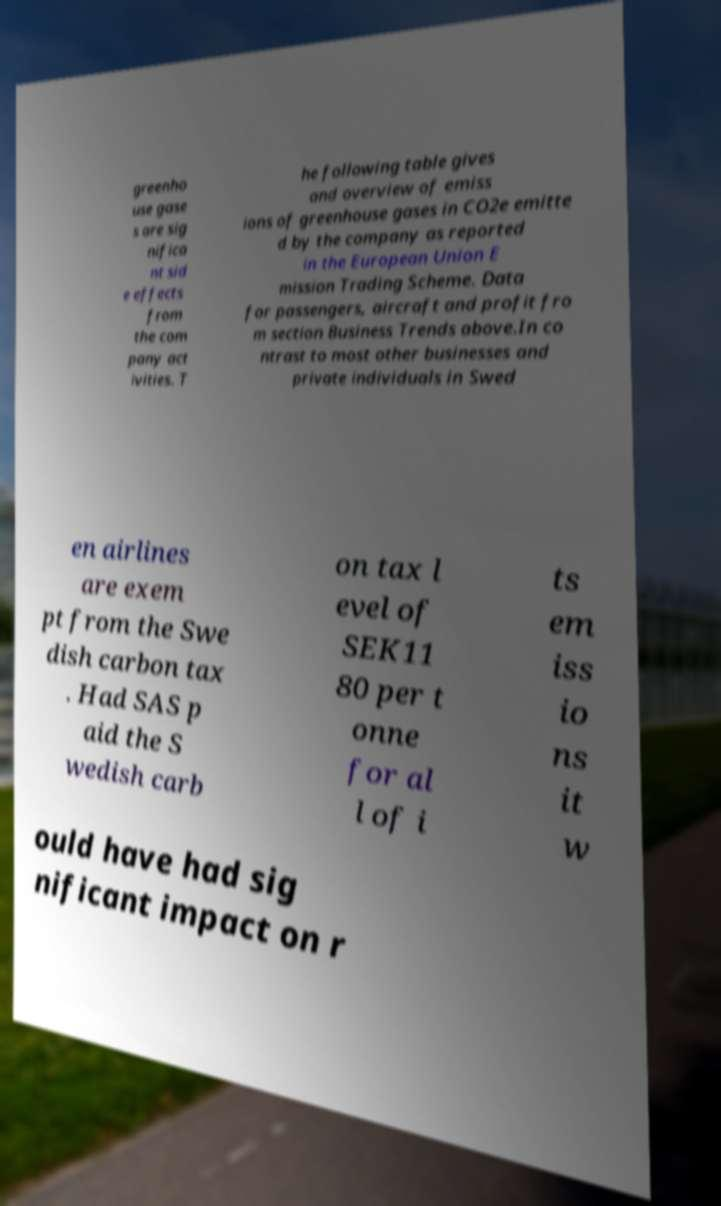What messages or text are displayed in this image? I need them in a readable, typed format. greenho use gase s are sig nifica nt sid e effects from the com pany act ivities. T he following table gives and overview of emiss ions of greenhouse gases in CO2e emitte d by the company as reported in the European Union E mission Trading Scheme. Data for passengers, aircraft and profit fro m section Business Trends above.In co ntrast to most other businesses and private individuals in Swed en airlines are exem pt from the Swe dish carbon tax . Had SAS p aid the S wedish carb on tax l evel of SEK11 80 per t onne for al l of i ts em iss io ns it w ould have had sig nificant impact on r 